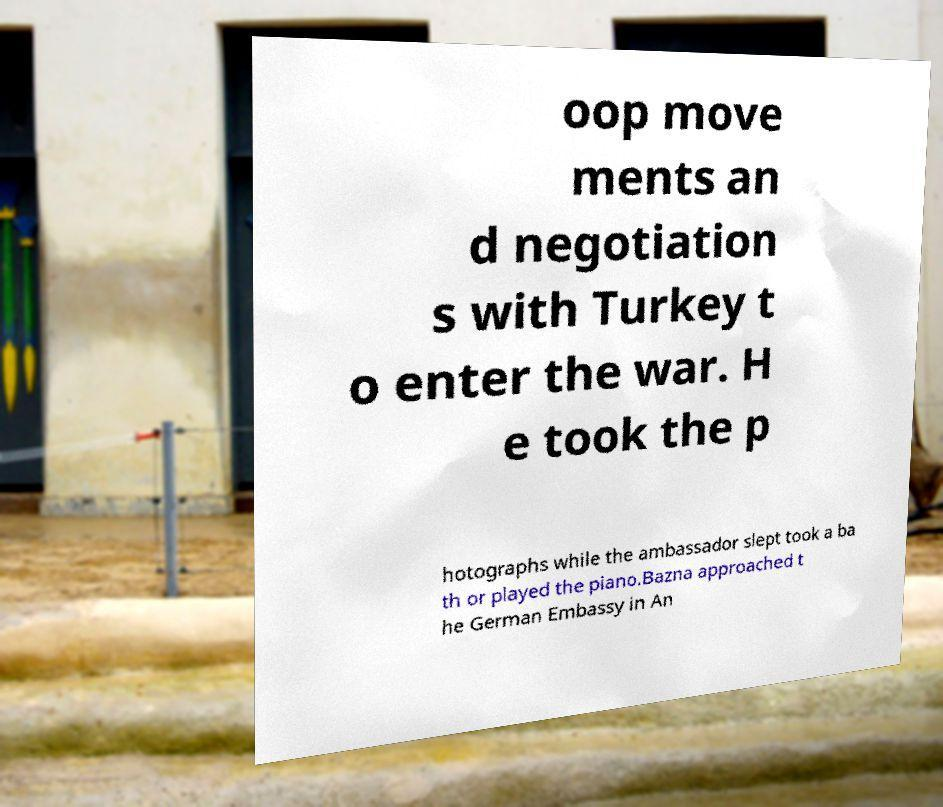What messages or text are displayed in this image? I need them in a readable, typed format. oop move ments an d negotiation s with Turkey t o enter the war. H e took the p hotographs while the ambassador slept took a ba th or played the piano.Bazna approached t he German Embassy in An 